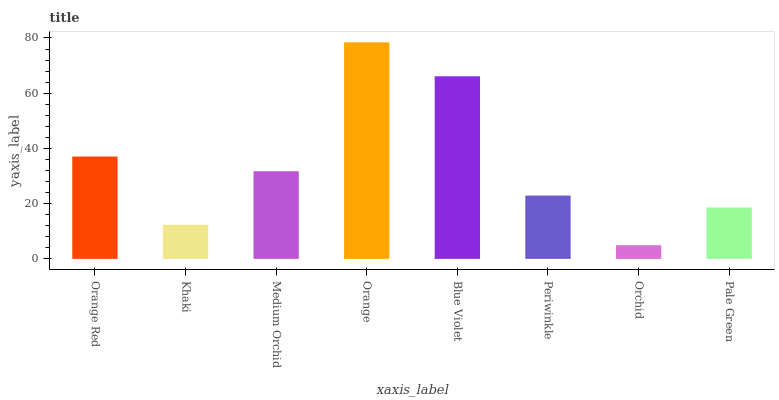Is Khaki the minimum?
Answer yes or no. No. Is Khaki the maximum?
Answer yes or no. No. Is Orange Red greater than Khaki?
Answer yes or no. Yes. Is Khaki less than Orange Red?
Answer yes or no. Yes. Is Khaki greater than Orange Red?
Answer yes or no. No. Is Orange Red less than Khaki?
Answer yes or no. No. Is Medium Orchid the high median?
Answer yes or no. Yes. Is Periwinkle the low median?
Answer yes or no. Yes. Is Orchid the high median?
Answer yes or no. No. Is Medium Orchid the low median?
Answer yes or no. No. 